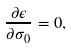Convert formula to latex. <formula><loc_0><loc_0><loc_500><loc_500>\frac { \partial \epsilon } { \partial \sigma _ { 0 } } = 0 ,</formula> 